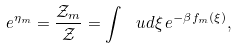Convert formula to latex. <formula><loc_0><loc_0><loc_500><loc_500>e ^ { \eta _ { m } } = \frac { \mathcal { Z } _ { m } } { \mathcal { Z } } = \int \, \ u d \xi \, e ^ { - \beta f _ { m } ( \xi ) } ,</formula> 